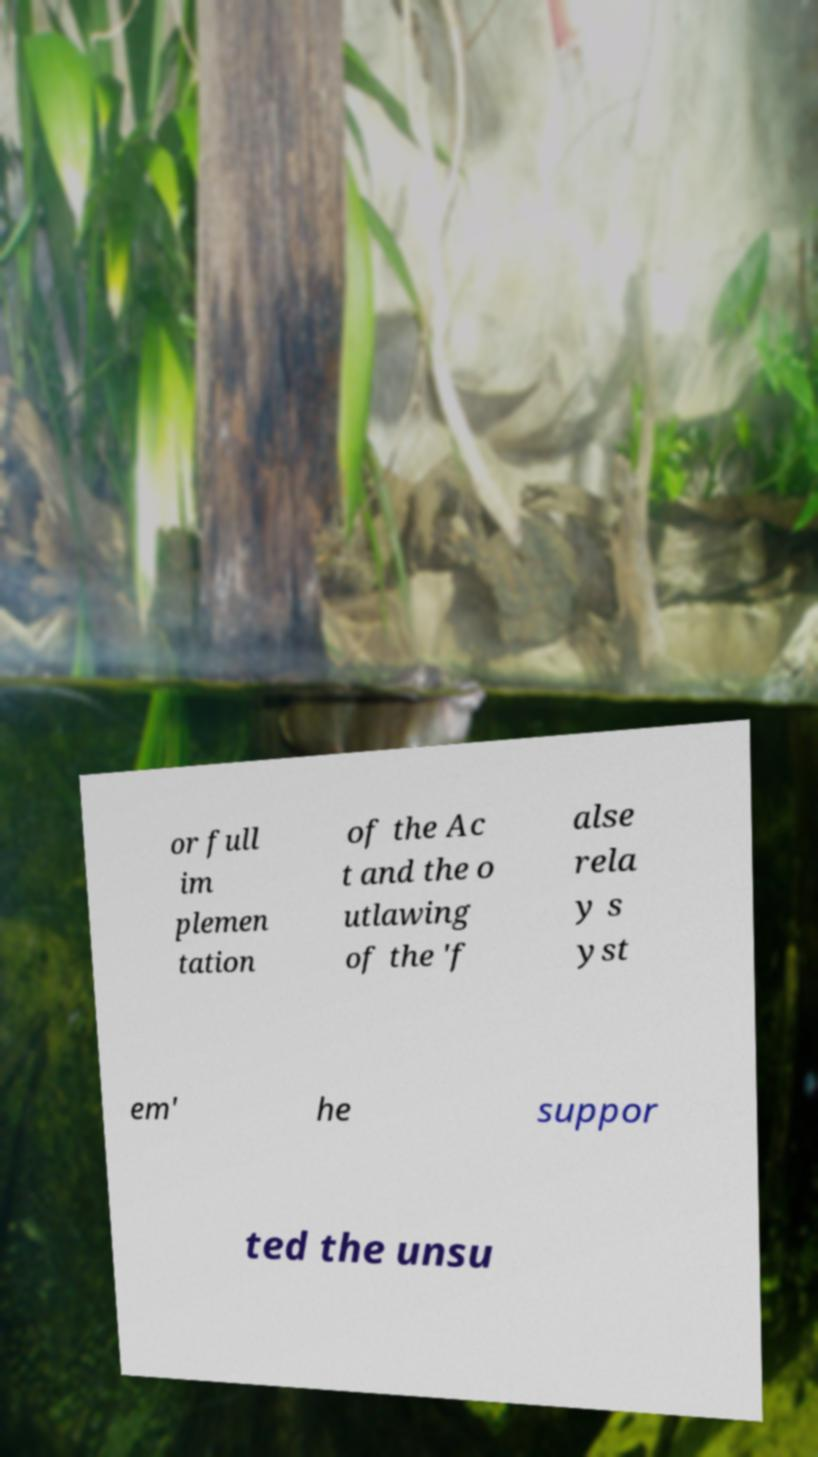Could you extract and type out the text from this image? or full im plemen tation of the Ac t and the o utlawing of the 'f alse rela y s yst em' he suppor ted the unsu 